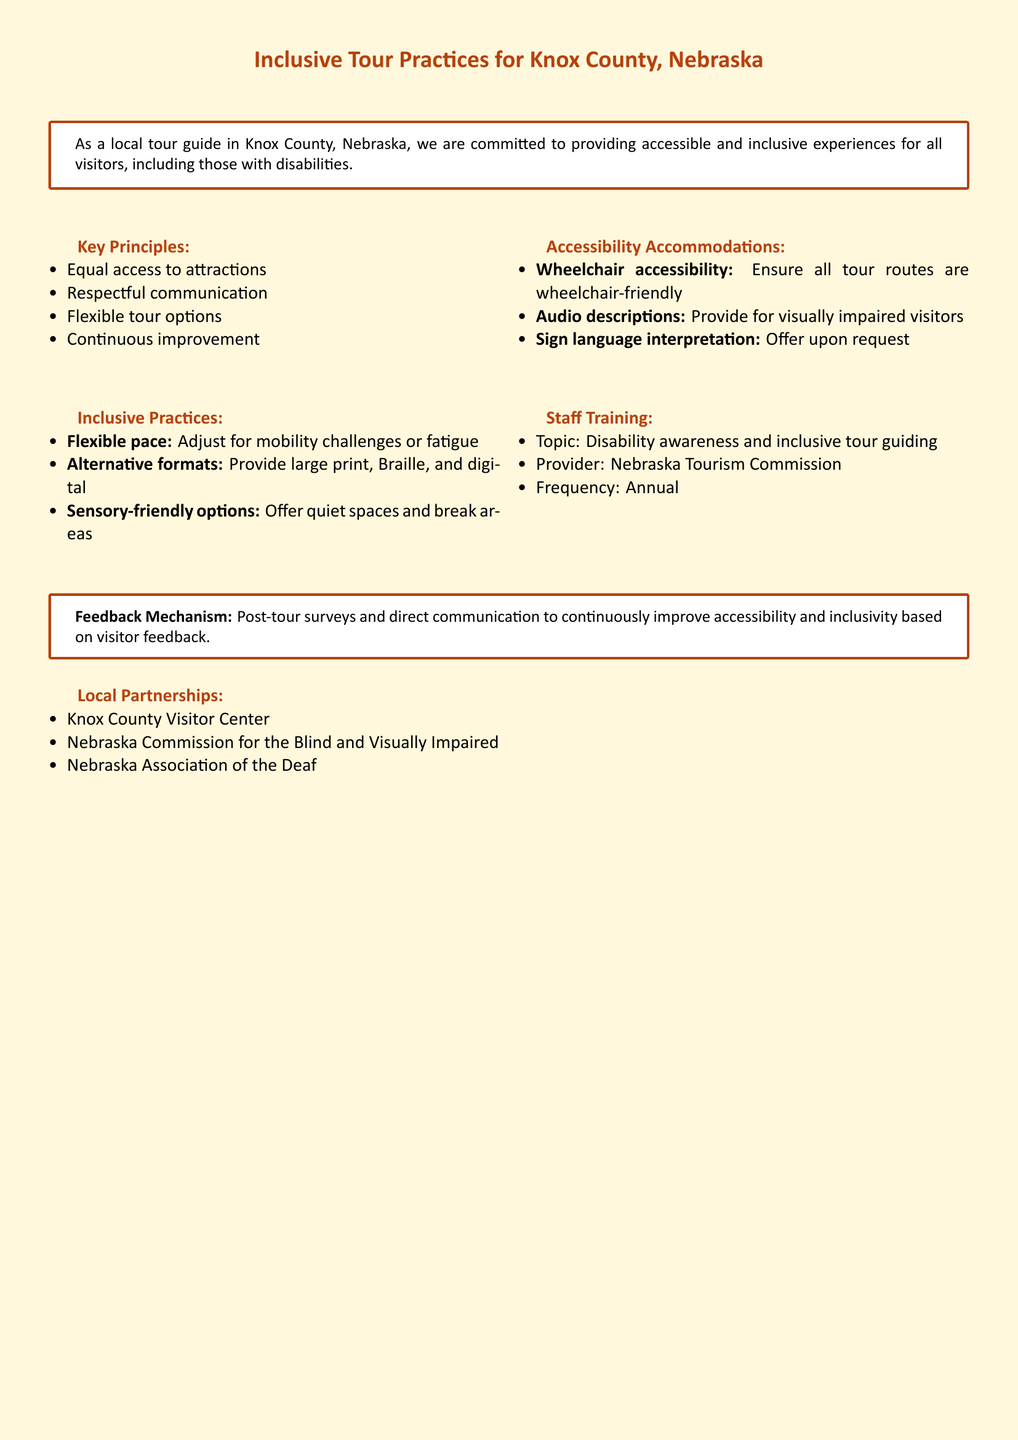What are the key principles of inclusive tour practices? The key principles are listed under "Key Principles" in the document, which includes equal access, respectful communication, flexible tour options, and continuous improvement.
Answer: Equal access, respectful communication, flexible tour options, continuous improvement What type of accessibility accommodations are mentioned? The document lists specific accommodations under "Accessibility Accommodations," including wheelchair accessibility, audio descriptions, and sign language interpretation.
Answer: Wheelchair accessibility, audio descriptions, sign language interpretation Who provides the staff training on disability awareness? The document states that the Nebraska Tourism Commission is the provider for staff training on disability awareness and inclusive tour guiding.
Answer: Nebraska Tourism Commission What is the frequency of staff training? According to the document, the frequency of staff training is specified in the "Staff Training" section.
Answer: Annual What should visitors do to provide feedback? The document mentions that visitors can provide feedback through post-tour surveys and direct communication.
Answer: Post-tour surveys and direct communication What options are available for sensory-friendly practices? The document outlines sensory-friendly options offered for visitors, which include quiet spaces and break areas.
Answer: Quiet spaces and break areas Which local partner is mentioned for supporting the visually impaired? The document lists the Nebraska Commission for the Blind and Visually Impaired as a local partner.
Answer: Nebraska Commission for the Blind and Visually Impaired How does the document suggest improving accessibility continuously? The feedback mechanism is specified in the document, which highlights the importance of continuous improvement based on visitor feedback.
Answer: Visitor feedback 